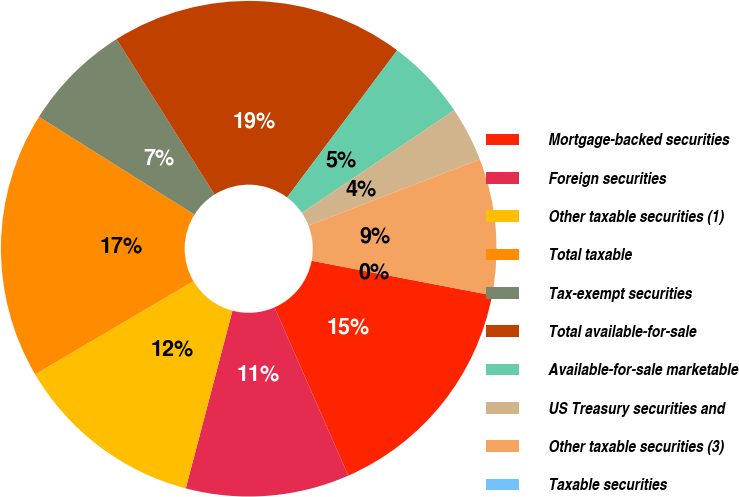Convert chart to OTSL. <chart><loc_0><loc_0><loc_500><loc_500><pie_chart><fcel>Mortgage-backed securities<fcel>Foreign securities<fcel>Other taxable securities (1)<fcel>Total taxable<fcel>Tax-exempt securities<fcel>Total available-for-sale<fcel>Available-for-sale marketable<fcel>US Treasury securities and<fcel>Other taxable securities (3)<fcel>Taxable securities<nl><fcel>15.41%<fcel>10.67%<fcel>12.45%<fcel>17.4%<fcel>7.11%<fcel>19.18%<fcel>5.34%<fcel>3.56%<fcel>8.89%<fcel>0.0%<nl></chart> 